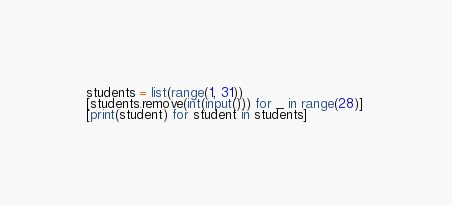<code> <loc_0><loc_0><loc_500><loc_500><_Python_>students = list(range(1, 31))
[students.remove(int(input())) for _ in range(28)] 
[print(student) for student in students]</code> 